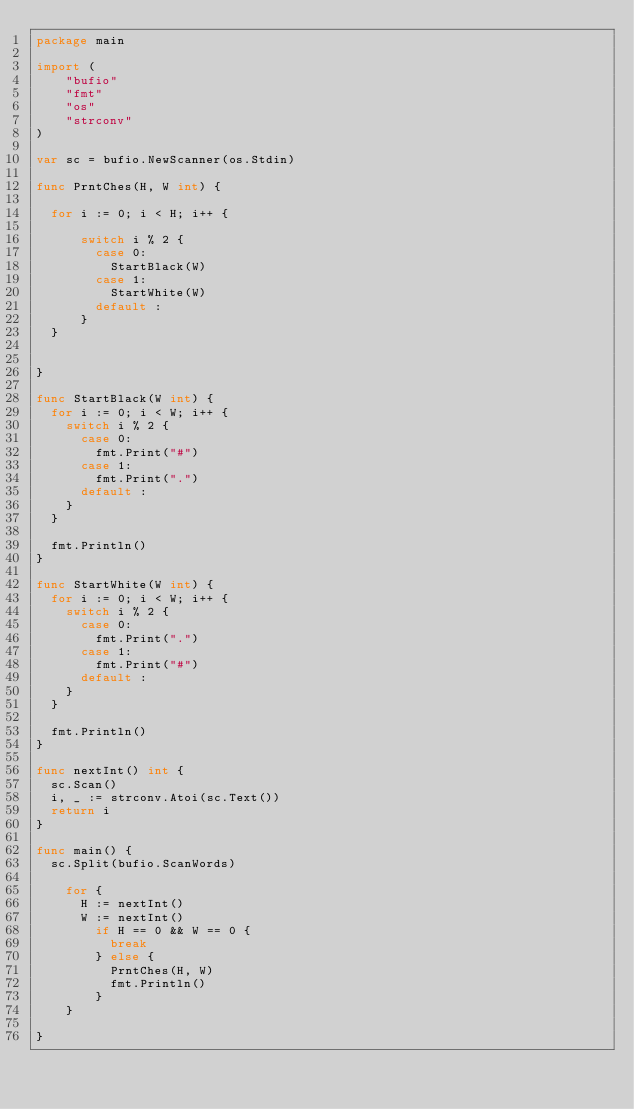Convert code to text. <code><loc_0><loc_0><loc_500><loc_500><_Go_>package main

import (
    "bufio"
    "fmt"
    "os"
    "strconv"
)

var sc = bufio.NewScanner(os.Stdin)

func PrntChes(H, W int) {

	for i := 0; i < H; i++ {
			
			switch i % 2 {
				case 0:
					StartBlack(W)
				case 1:
					StartWhite(W)
				default :
			}
	}

	
}

func StartBlack(W int) {
	for i := 0; i < W; i++ {
		switch i % 2 {
			case 0:
				fmt.Print("#")
			case 1:
				fmt.Print(".")
			default :
		}
	}

	fmt.Println()
}

func StartWhite(W int) {
	for i := 0; i < W; i++ {
		switch i % 2 {
			case 0:
				fmt.Print(".")
			case 1:
				fmt.Print("#")
			default :
		}
	}

	fmt.Println()
}

func nextInt() int {
	sc.Scan()
	i, _ := strconv.Atoi(sc.Text())
	return i
}

func main() {
	sc.Split(bufio.ScanWords)
	
		for {
			H := nextInt()
			W := nextInt()
				if H == 0 && W == 0 {
					break
				} else {
					PrntChes(H, W)
					fmt.Println()
				}
		}
	
}
</code> 